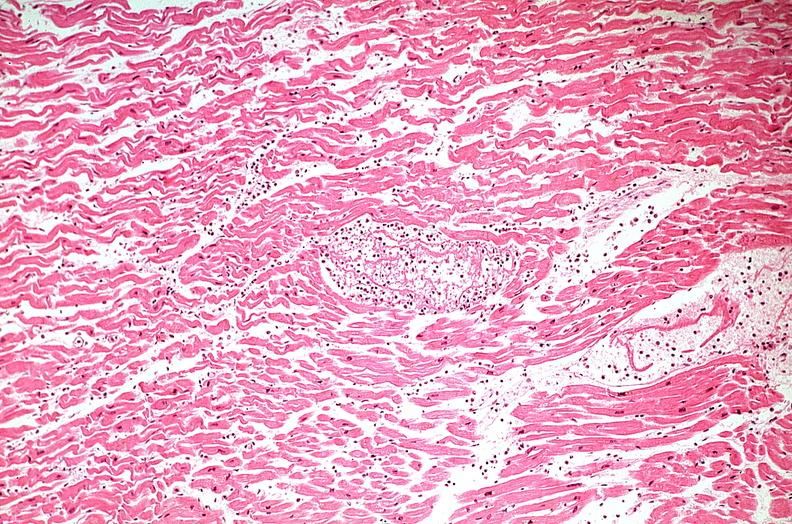what is present?
Answer the question using a single word or phrase. Cardiovascular 